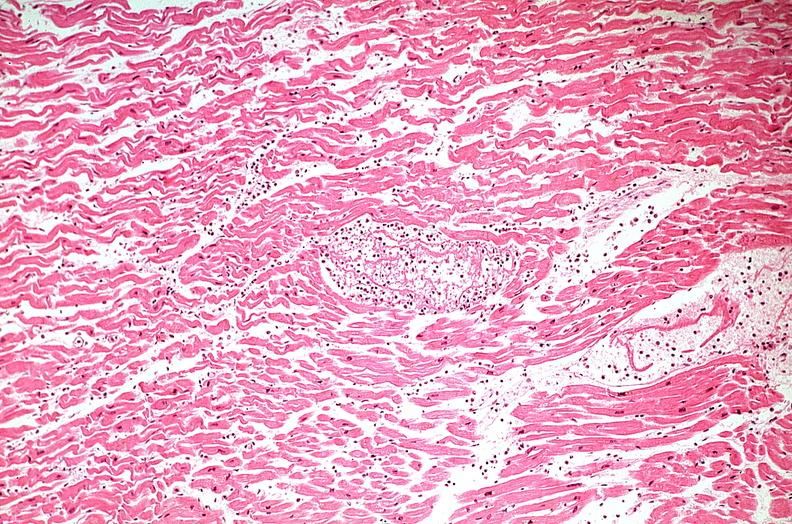what is present?
Answer the question using a single word or phrase. Cardiovascular 